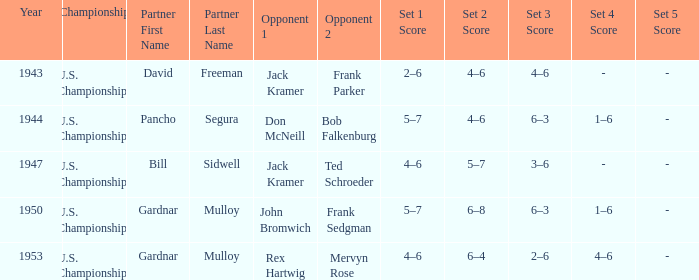Which Score has Opponents in the final of john bromwich frank sedgman? 5–7, 6–8, 6–3, 1–6. 